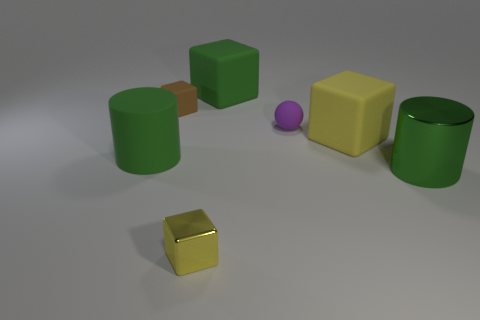How many large things are brown cubes or cylinders?
Offer a terse response. 2. How many other objects are the same color as the metallic cube?
Your answer should be compact. 1. There is a tiny block behind the block in front of the big green metallic thing; what number of big cubes are behind it?
Keep it short and to the point. 1. There is a cube behind the brown block; is its size the same as the brown matte cube?
Provide a succinct answer. No. Is the number of small purple matte objects that are behind the brown thing less than the number of green blocks that are left of the small rubber ball?
Provide a short and direct response. Yes. Do the large metal object and the large rubber cylinder have the same color?
Offer a terse response. Yes. Are there fewer big green rubber objects in front of the big green metal cylinder than tiny rubber cubes?
Provide a short and direct response. Yes. There is a block that is the same color as the metal cylinder; what is it made of?
Keep it short and to the point. Rubber. Is the large yellow thing made of the same material as the small brown block?
Give a very brief answer. Yes. How many other small objects are the same material as the brown thing?
Make the answer very short. 1. 